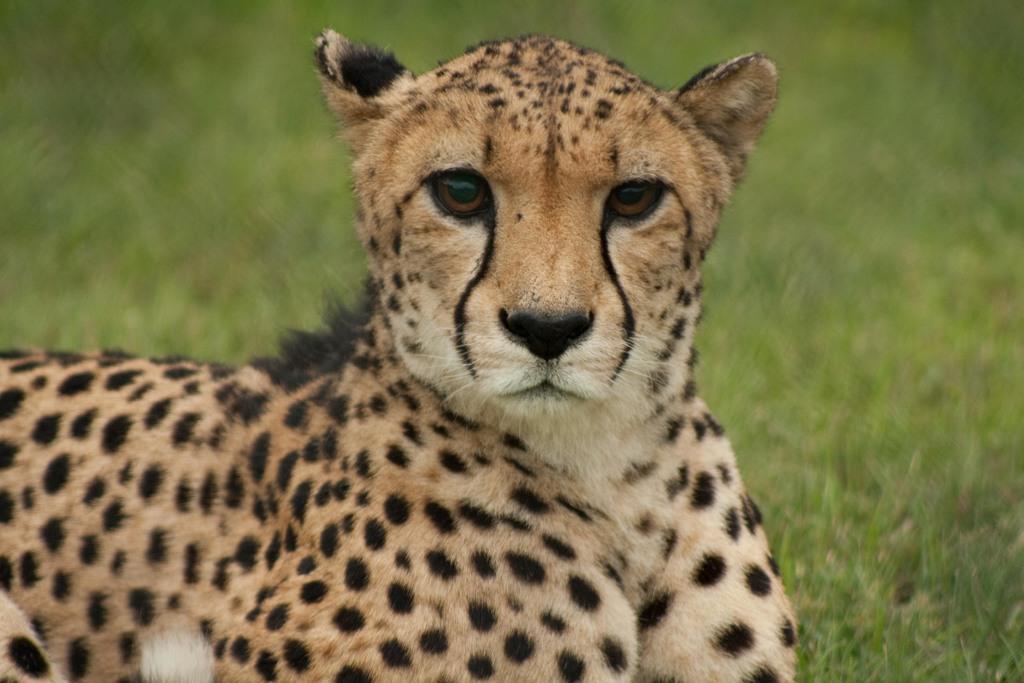How would you summarize this image in a sentence or two? In this image I can see an animal which is in brown, white and black color. In the background I can see the grass but it is blurry. 